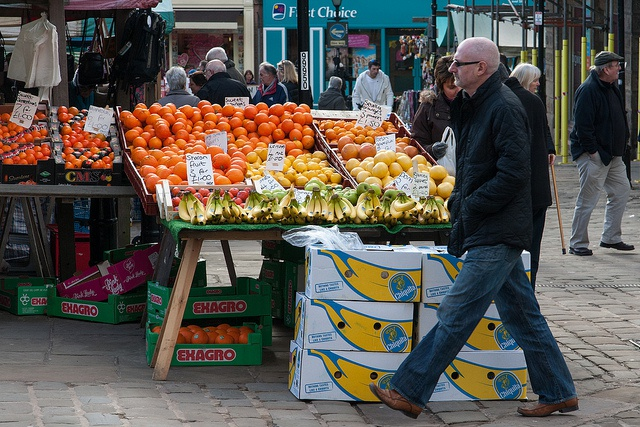Describe the objects in this image and their specific colors. I can see people in black, darkblue, blue, and gray tones, orange in black, red, brown, and salmon tones, people in black, gray, and darkgray tones, people in black, gray, and darkgray tones, and people in black, darkgray, gray, and maroon tones in this image. 